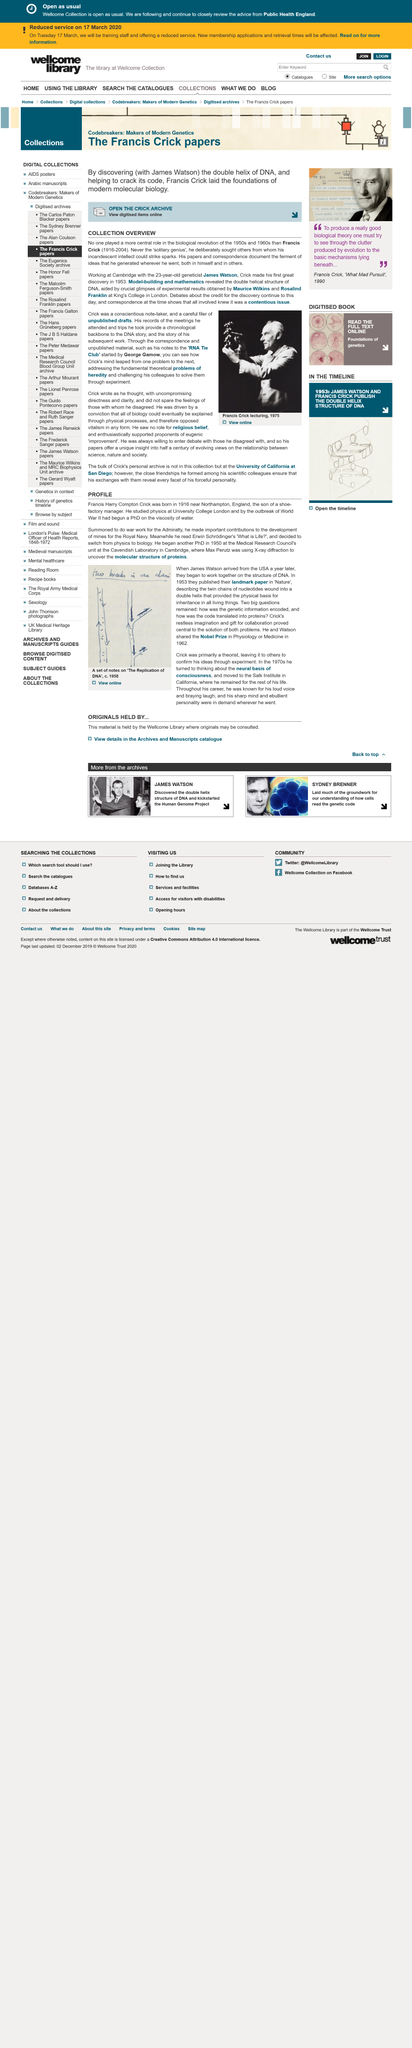Specify some key components in this picture. In the 1950s, James Watson, a geneticist who worked at Cambridge University with Francis Crick, played a pivotal role in the discovery of the structure of DNA. Francis Harry Compton Crick, a British molecular biologist, was born near Northampton, England. Model-building and mathematics played a critical role in revealing the double helical structure of DNA, which is a fundamental aspect of genetic information storage and replication. In 1916, Francis Harry Compton Crick was born. Francis Crick, a key figure in the biological revolution of the 1950s and 1960s, was born in 1916. 